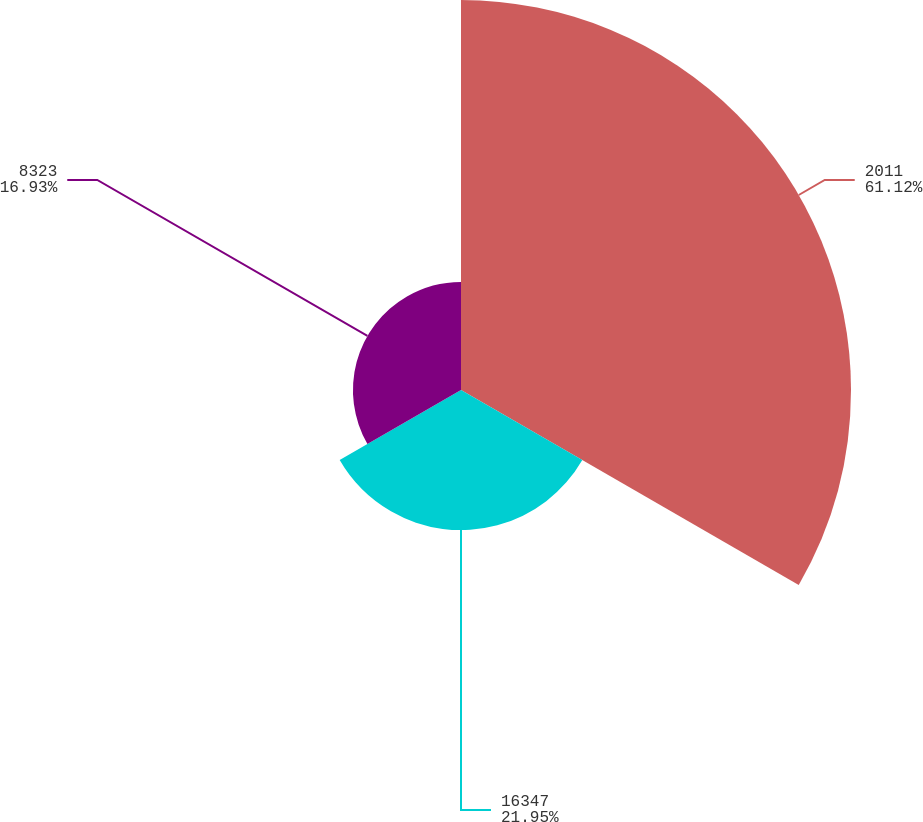<chart> <loc_0><loc_0><loc_500><loc_500><pie_chart><fcel>2011<fcel>16347<fcel>8323<nl><fcel>61.11%<fcel>21.95%<fcel>16.93%<nl></chart> 